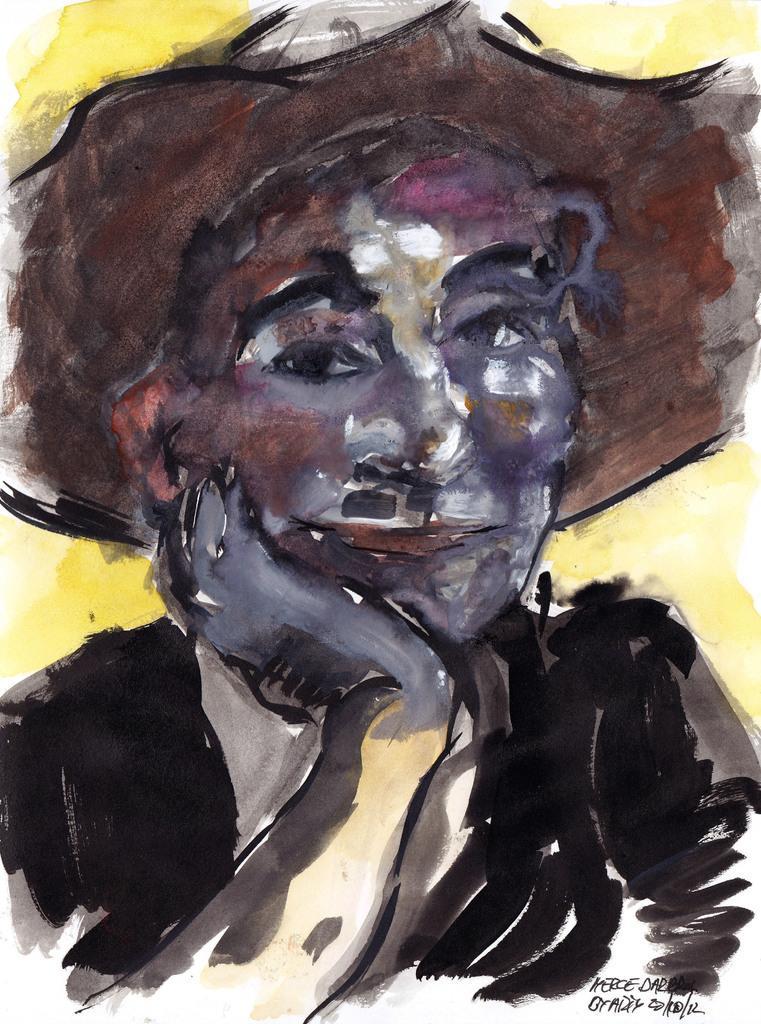Could you give a brief overview of what you see in this image? In the center of the image we can see one painting, in which we can see one person wearing a hat. In the bottom right side of the image, we can see some text. 